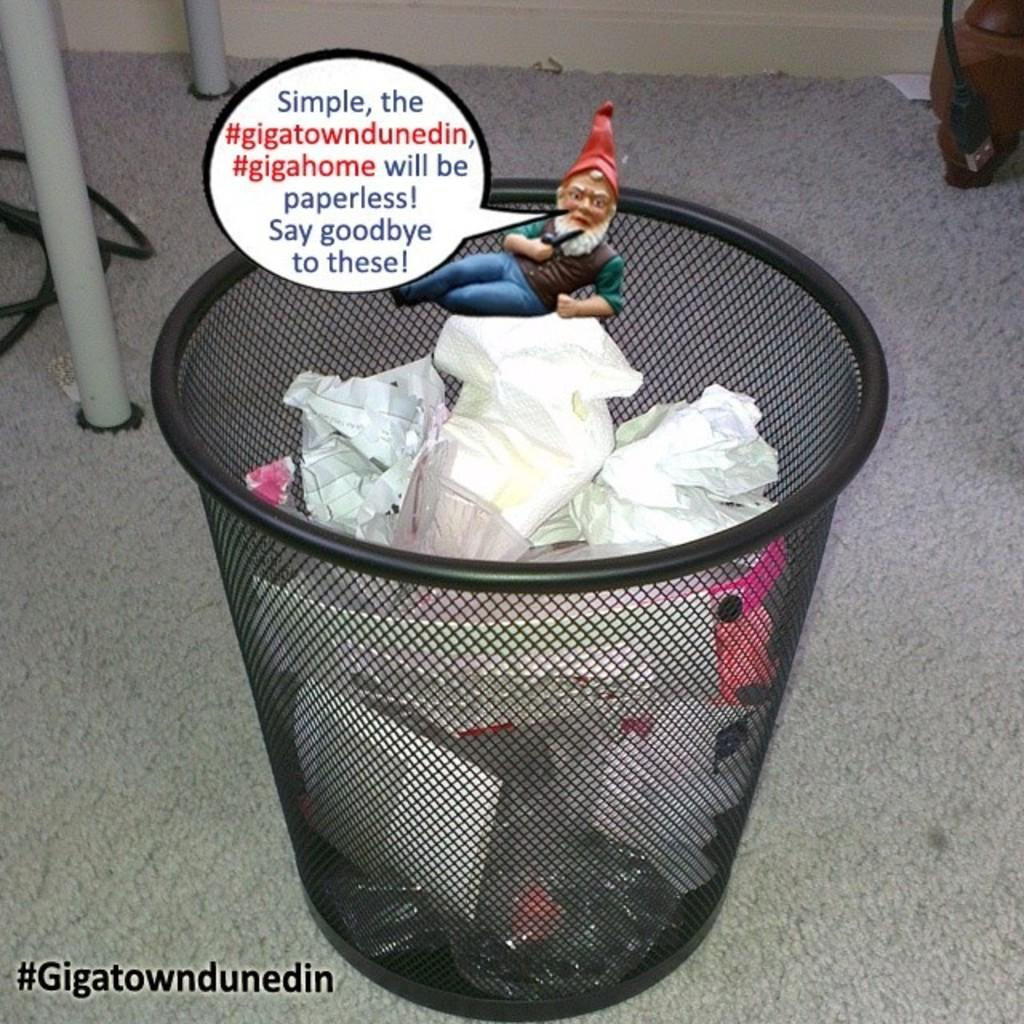<image>
Provide a brief description of the given image. A meme for the gigatown dunedein being paperless. 